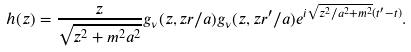Convert formula to latex. <formula><loc_0><loc_0><loc_500><loc_500>h ( z ) = \frac { z } { \sqrt { z ^ { 2 } + m ^ { 2 } a ^ { 2 } } } g _ { \nu } ( z , z r / a ) g _ { \nu } ( z , z r ^ { \prime } / a ) e ^ { i \sqrt { z ^ { 2 } / a ^ { 2 } + m ^ { 2 } } ( t ^ { \prime } - t ) } .</formula> 